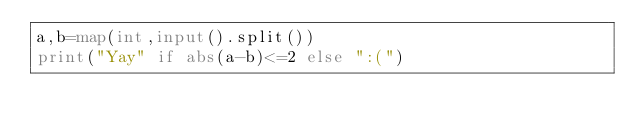Convert code to text. <code><loc_0><loc_0><loc_500><loc_500><_Python_>a,b=map(int,input().split())
print("Yay" if abs(a-b)<=2 else ":(")</code> 